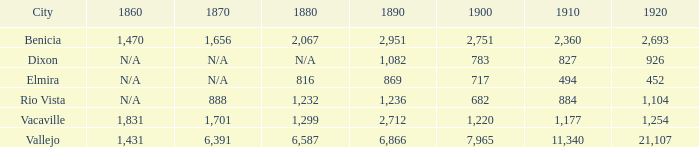What is the 1920 number when 1890 is greater than 1,236, 1910 is less than 1,177 and the city is Vacaville? None. 